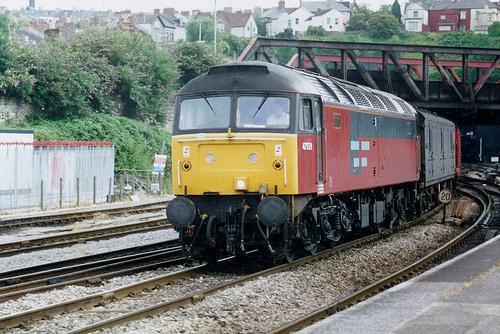How many cows are standing on the right side of the train?
Give a very brief answer. 0. 